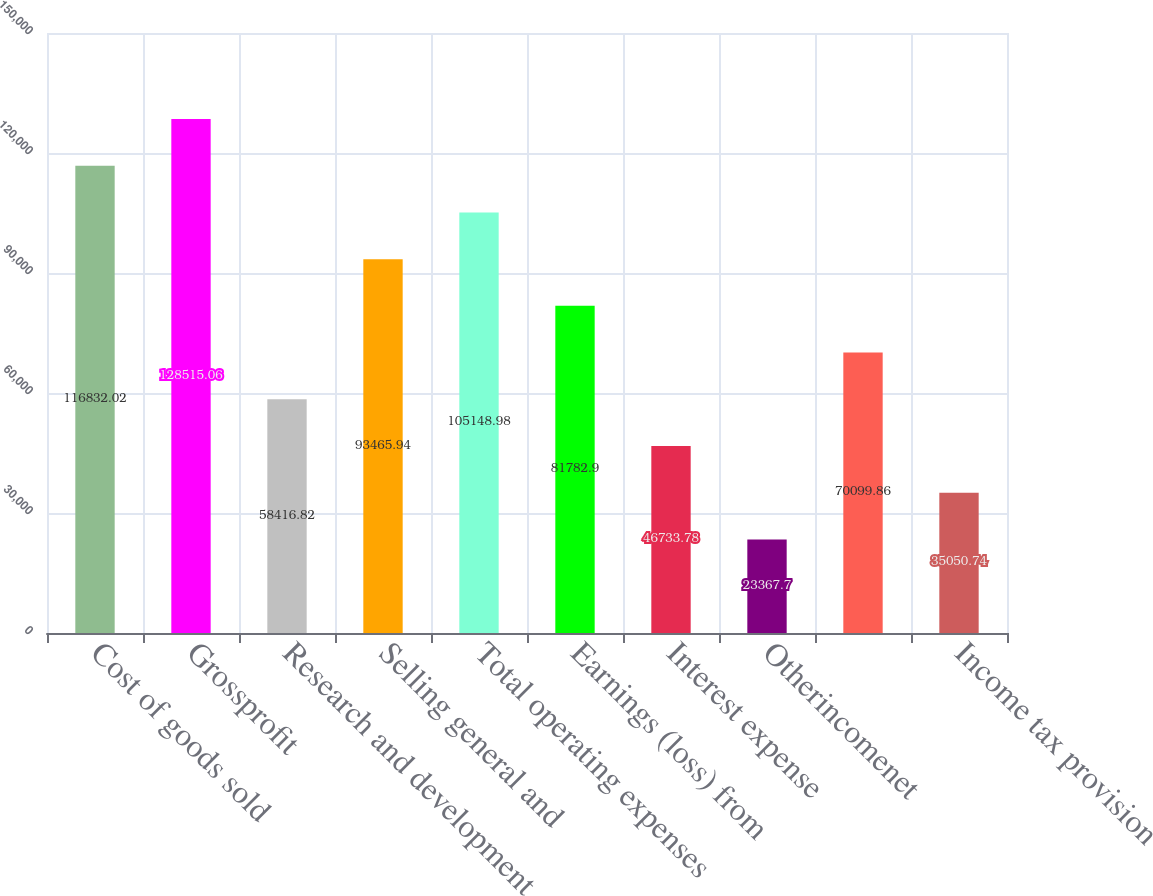Convert chart to OTSL. <chart><loc_0><loc_0><loc_500><loc_500><bar_chart><fcel>Cost of goods sold<fcel>Grossprofit<fcel>Research and development<fcel>Selling general and<fcel>Total operating expenses<fcel>Earnings (loss) from<fcel>Interest expense<fcel>Otherincomenet<fcel>Unnamed: 8<fcel>Income tax provision<nl><fcel>116832<fcel>128515<fcel>58416.8<fcel>93465.9<fcel>105149<fcel>81782.9<fcel>46733.8<fcel>23367.7<fcel>70099.9<fcel>35050.7<nl></chart> 